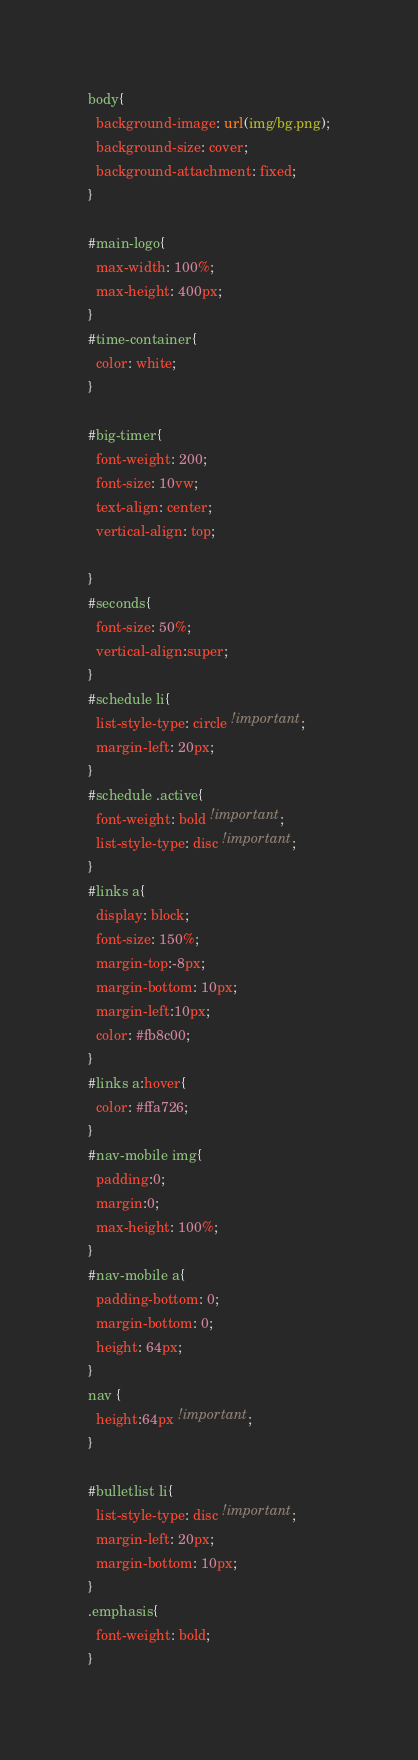Convert code to text. <code><loc_0><loc_0><loc_500><loc_500><_CSS_>body{
  background-image: url(img/bg.png);
  background-size: cover;
  background-attachment: fixed;
}

#main-logo{
  max-width: 100%;
  max-height: 400px;
}
#time-container{
  color: white;
}

#big-timer{
  font-weight: 200;
  font-size: 10vw;
  text-align: center;
  vertical-align: top;

}
#seconds{
  font-size: 50%;
  vertical-align:super;
}
#schedule li{
  list-style-type: circle !important;
  margin-left: 20px;
}
#schedule .active{
  font-weight: bold !important;
  list-style-type: disc !important;
}
#links a{
  display: block;
  font-size: 150%;
  margin-top:-8px;
  margin-bottom: 10px;
  margin-left:10px;
  color: #fb8c00;
}
#links a:hover{
  color: #ffa726;
}
#nav-mobile img{
  padding:0;
  margin:0;
  max-height: 100%;
}
#nav-mobile a{
  padding-bottom: 0;
  margin-bottom: 0;
  height: 64px;
}
nav {
  height:64px !important;
}

#bulletlist li{
  list-style-type: disc !important;
  margin-left: 20px;
  margin-bottom: 10px;
}
.emphasis{
  font-weight: bold;
}</code> 